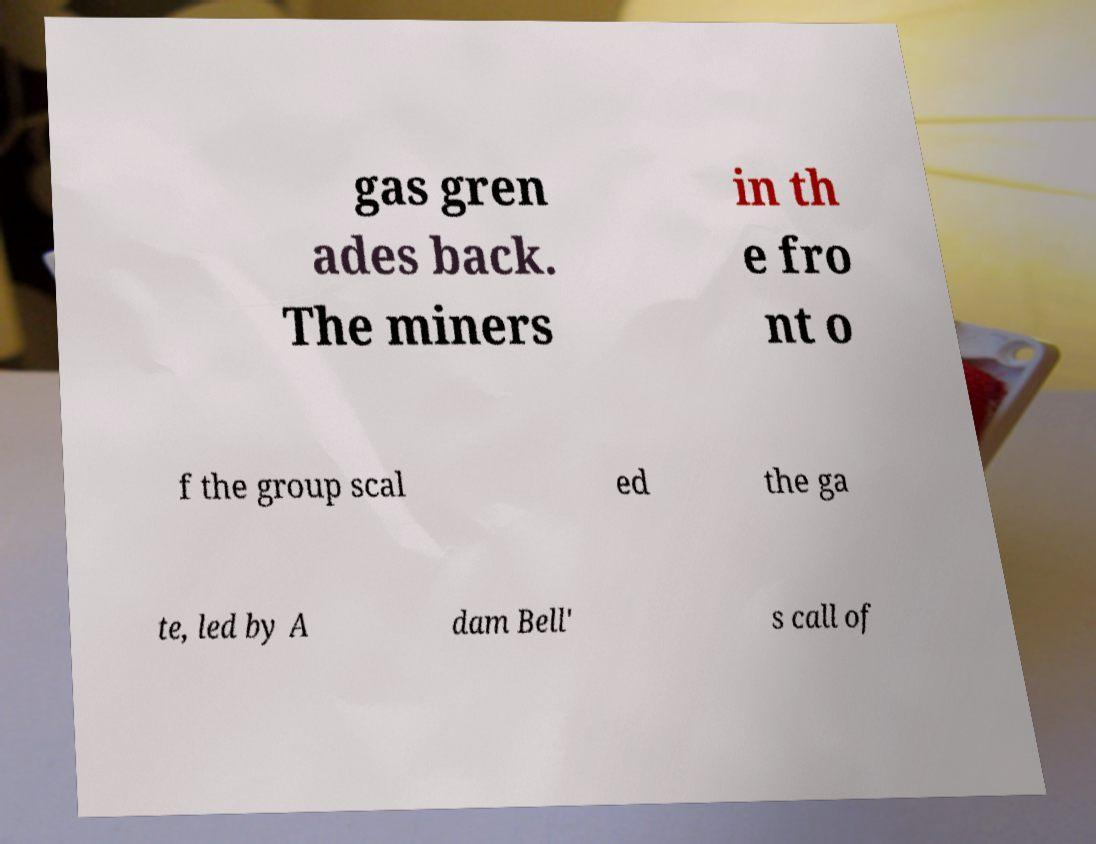For documentation purposes, I need the text within this image transcribed. Could you provide that? gas gren ades back. The miners in th e fro nt o f the group scal ed the ga te, led by A dam Bell' s call of 